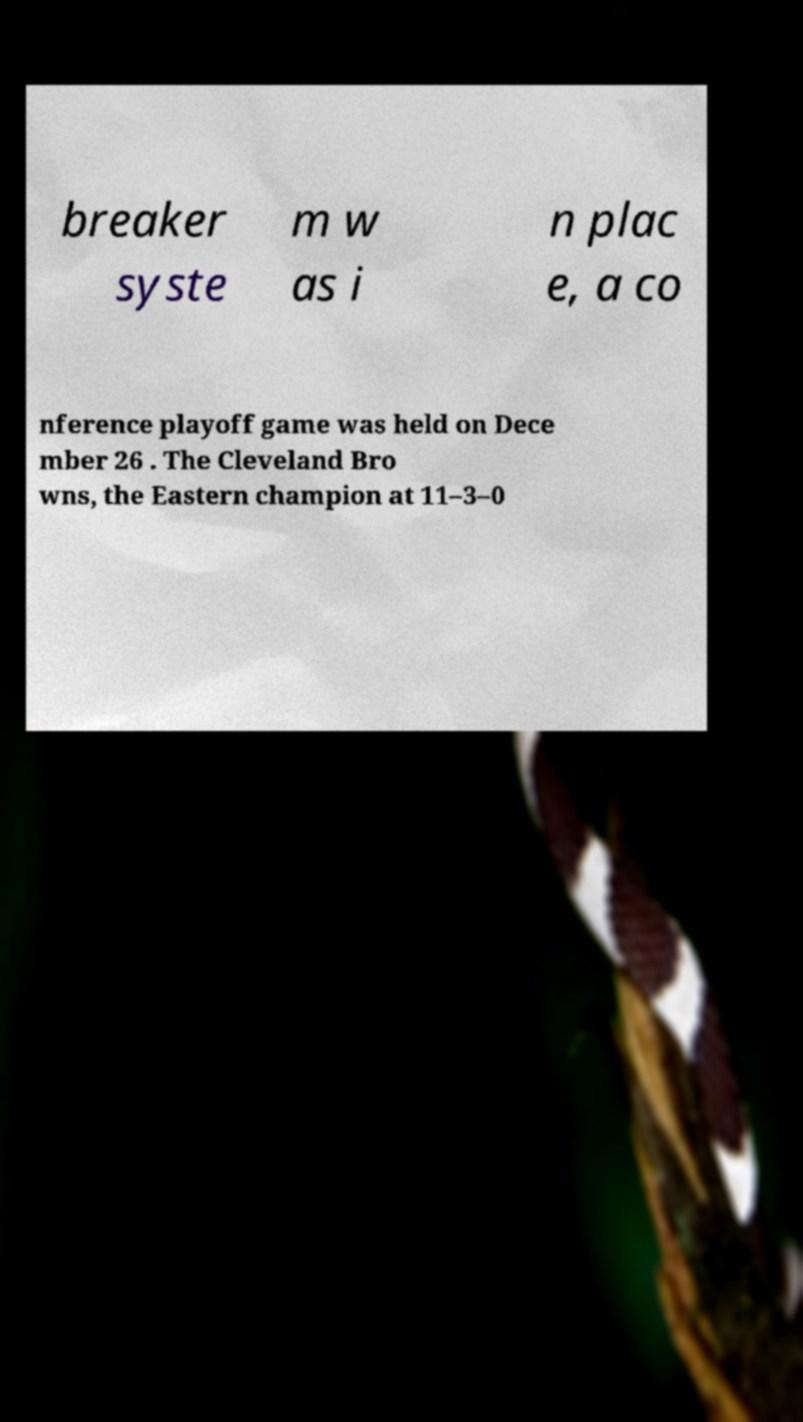Could you extract and type out the text from this image? breaker syste m w as i n plac e, a co nference playoff game was held on Dece mber 26 . The Cleveland Bro wns, the Eastern champion at 11–3–0 